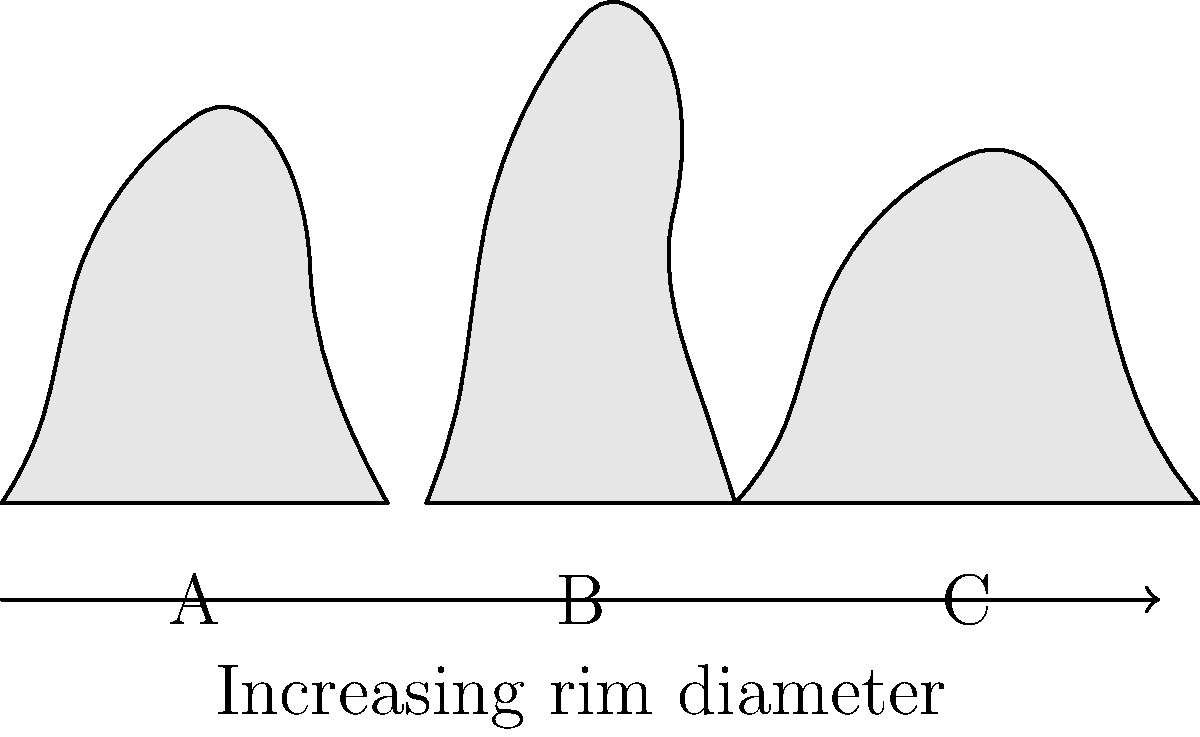Based on the shapes of the Neolithic pottery shown in the diagram, which type is most likely to be associated with the Early Neolithic period in Britain, characterized by its round-based form and simple design? To answer this question, we need to consider the characteristics of Early Neolithic pottery in Britain and compare them to the shapes presented in the diagram. Let's analyze each step:

1. Early Neolithic pottery characteristics:
   - Round-based form
   - Simple design
   - Often bowl-shaped or bag-shaped

2. Analysis of the shapes in the diagram:
   - Pot A: Wide rim, rounded base, relatively short height
   - Pot B: Narrow rim, elongated shape, taller than it is wide
   - Pot C: Very wide rim, squat shape, wider than it is tall

3. Comparison with Early Neolithic characteristics:
   - Pot A most closely resembles the round-based, simple form typical of Early Neolithic pottery
   - Pot B is too elongated and narrow-rimmed for typical Early Neolithic forms
   - Pot C has an exaggerated wide rim, which is not characteristic of Early Neolithic pottery

4. Historical context:
   - Early Neolithic pottery in Britain (c. 4000-3300 BCE) was often simple and functional
   - More complex forms and decorations developed in later Neolithic periods

Based on this analysis, Pot A is most likely to be associated with the Early Neolithic period in Britain due to its round-based form and simple design.
Answer: Pot A 